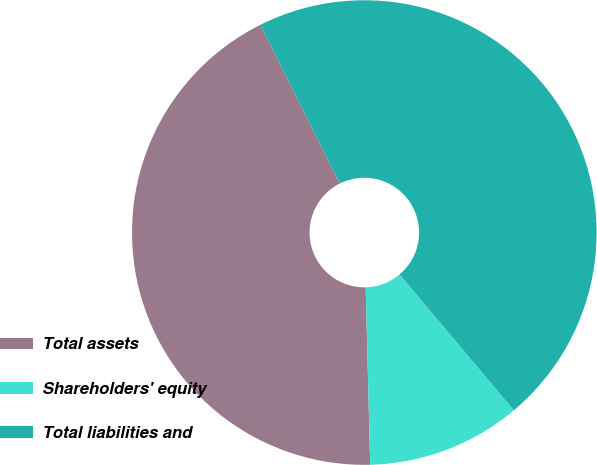<chart> <loc_0><loc_0><loc_500><loc_500><pie_chart><fcel>Total assets<fcel>Shareholders' equity<fcel>Total liabilities and<nl><fcel>43.02%<fcel>10.73%<fcel>46.25%<nl></chart> 